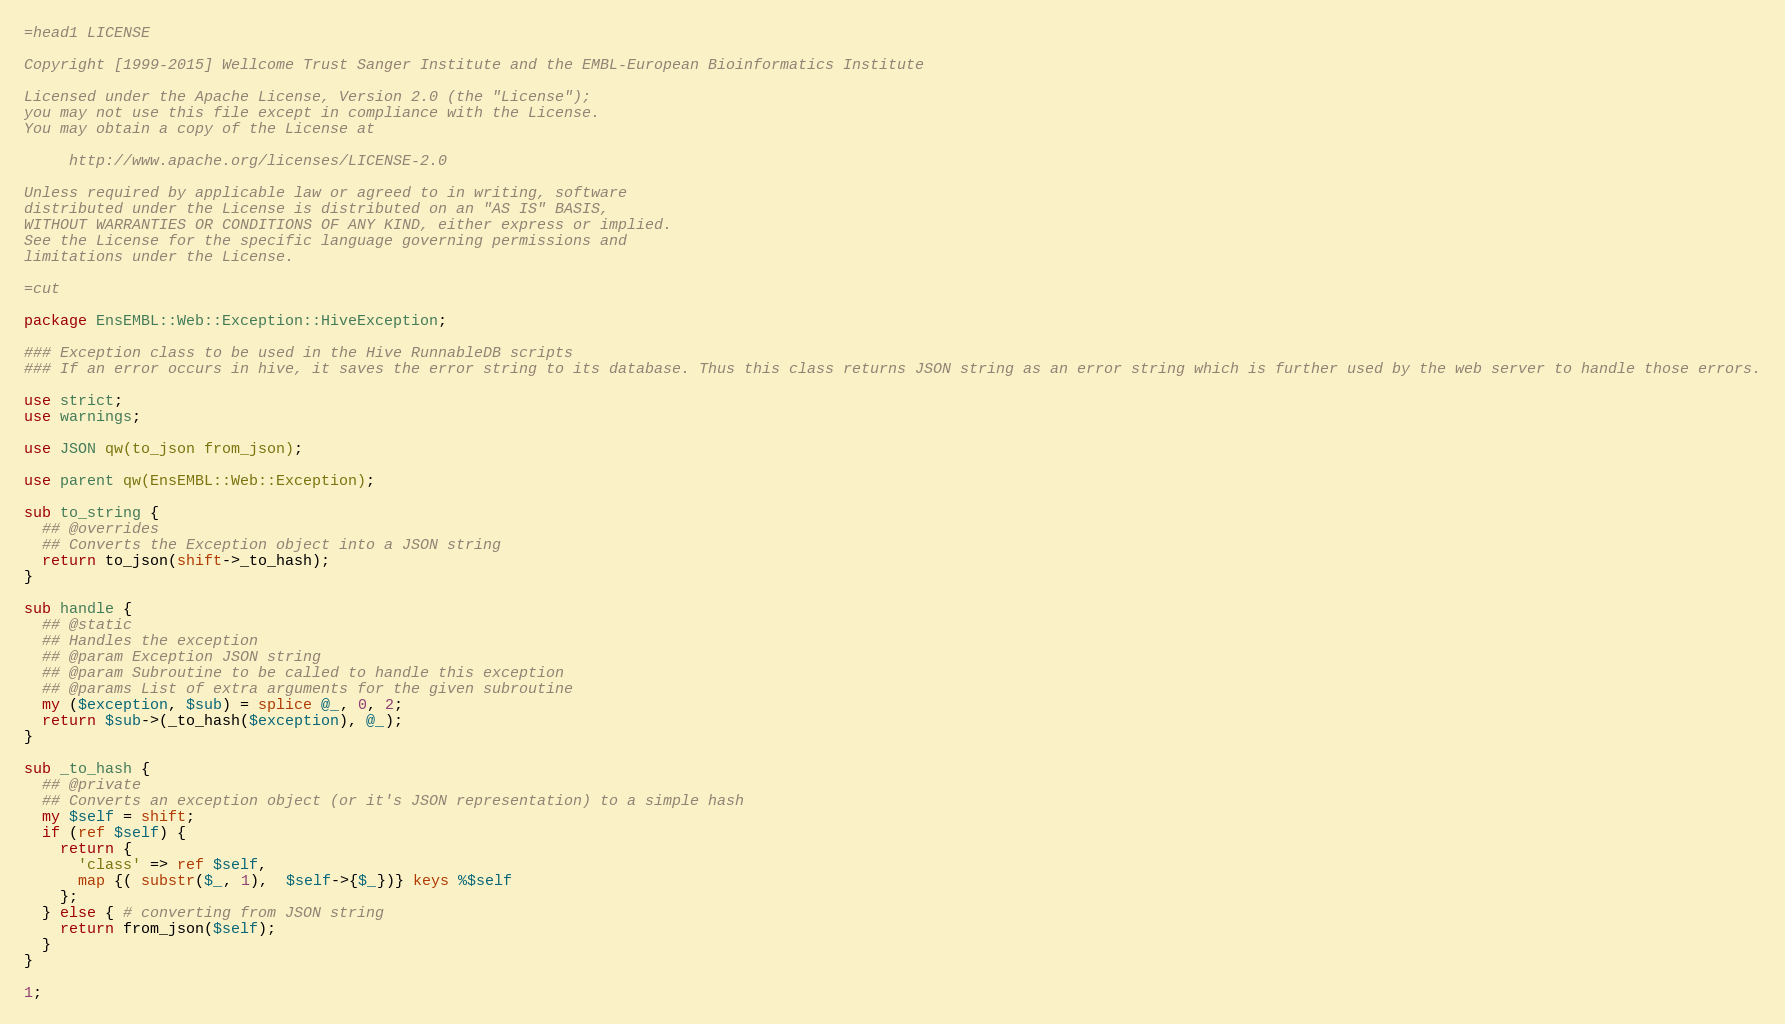Convert code to text. <code><loc_0><loc_0><loc_500><loc_500><_Perl_>=head1 LICENSE

Copyright [1999-2015] Wellcome Trust Sanger Institute and the EMBL-European Bioinformatics Institute

Licensed under the Apache License, Version 2.0 (the "License");
you may not use this file except in compliance with the License.
You may obtain a copy of the License at

     http://www.apache.org/licenses/LICENSE-2.0

Unless required by applicable law or agreed to in writing, software
distributed under the License is distributed on an "AS IS" BASIS,
WITHOUT WARRANTIES OR CONDITIONS OF ANY KIND, either express or implied.
See the License for the specific language governing permissions and
limitations under the License.

=cut

package EnsEMBL::Web::Exception::HiveException;

### Exception class to be used in the Hive RunnableDB scripts
### If an error occurs in hive, it saves the error string to its database. Thus this class returns JSON string as an error string which is further used by the web server to handle those errors.

use strict;
use warnings;

use JSON qw(to_json from_json);

use parent qw(EnsEMBL::Web::Exception);

sub to_string {
  ## @overrides
  ## Converts the Exception object into a JSON string
  return to_json(shift->_to_hash);
}

sub handle {
  ## @static
  ## Handles the exception
  ## @param Exception JSON string
  ## @param Subroutine to be called to handle this exception
  ## @params List of extra arguments for the given subroutine
  my ($exception, $sub) = splice @_, 0, 2;
  return $sub->(_to_hash($exception), @_);
}

sub _to_hash {
  ## @private
  ## Converts an exception object (or it's JSON representation) to a simple hash
  my $self = shift;
  if (ref $self) {
    return {
      'class' => ref $self,
      map {( substr($_, 1),  $self->{$_})} keys %$self
    };
  } else { # converting from JSON string
    return from_json($self);
  }
}

1;
</code> 